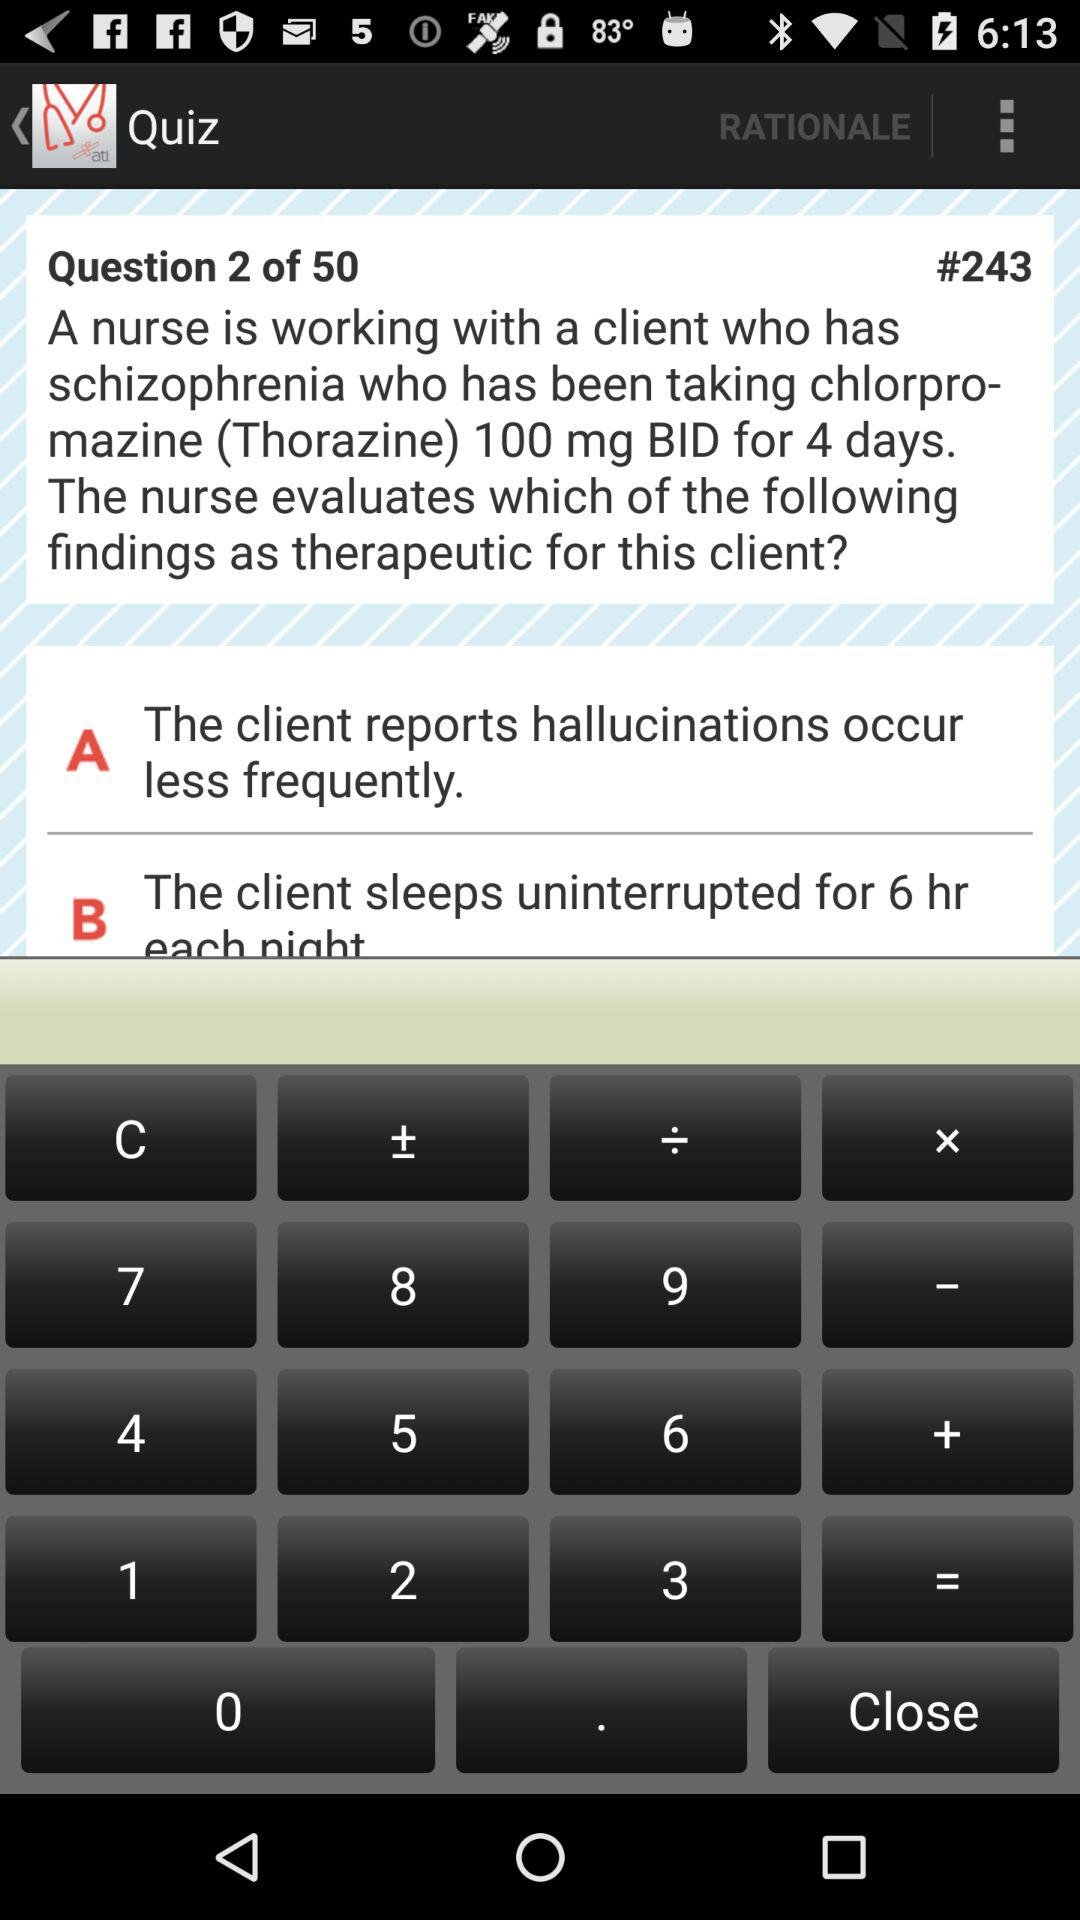How many quiz questions are there? There are 50 quiz questions. 